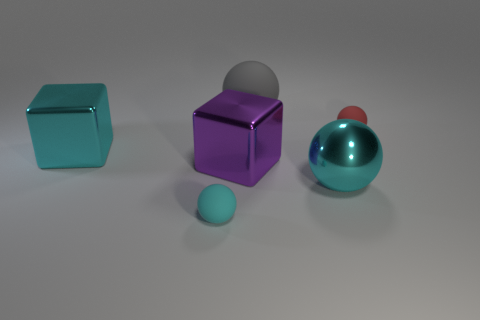Subtract all big gray balls. How many balls are left? 3 Subtract all blocks. How many objects are left? 4 Add 3 tiny gray matte cubes. How many objects exist? 9 Subtract all purple blocks. How many blocks are left? 1 Subtract all blue cylinders. How many red blocks are left? 0 Subtract all large matte balls. Subtract all large blue metallic blocks. How many objects are left? 5 Add 5 large cyan objects. How many large cyan objects are left? 7 Add 1 cyan metal blocks. How many cyan metal blocks exist? 2 Subtract 1 gray spheres. How many objects are left? 5 Subtract 2 balls. How many balls are left? 2 